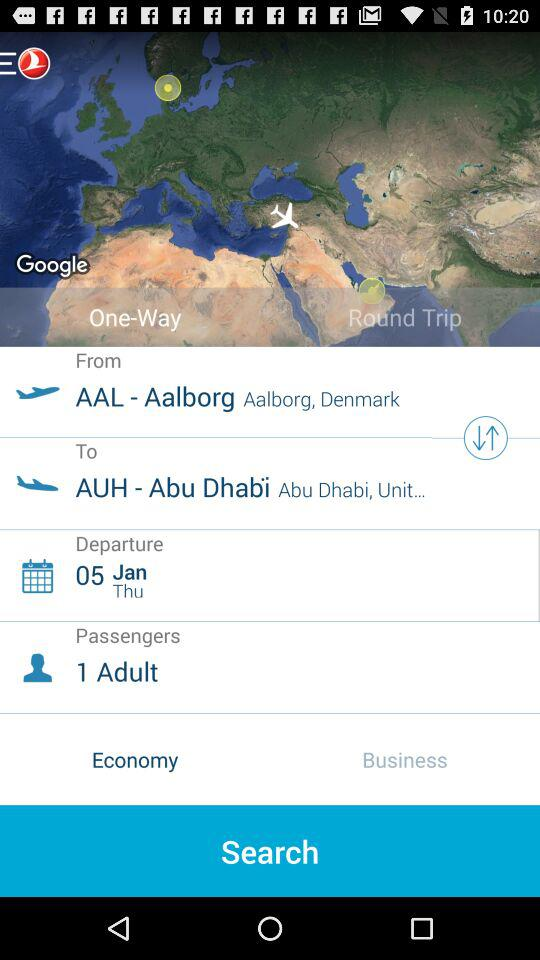What is the departure date? The departure date is Thursday, January 5. 